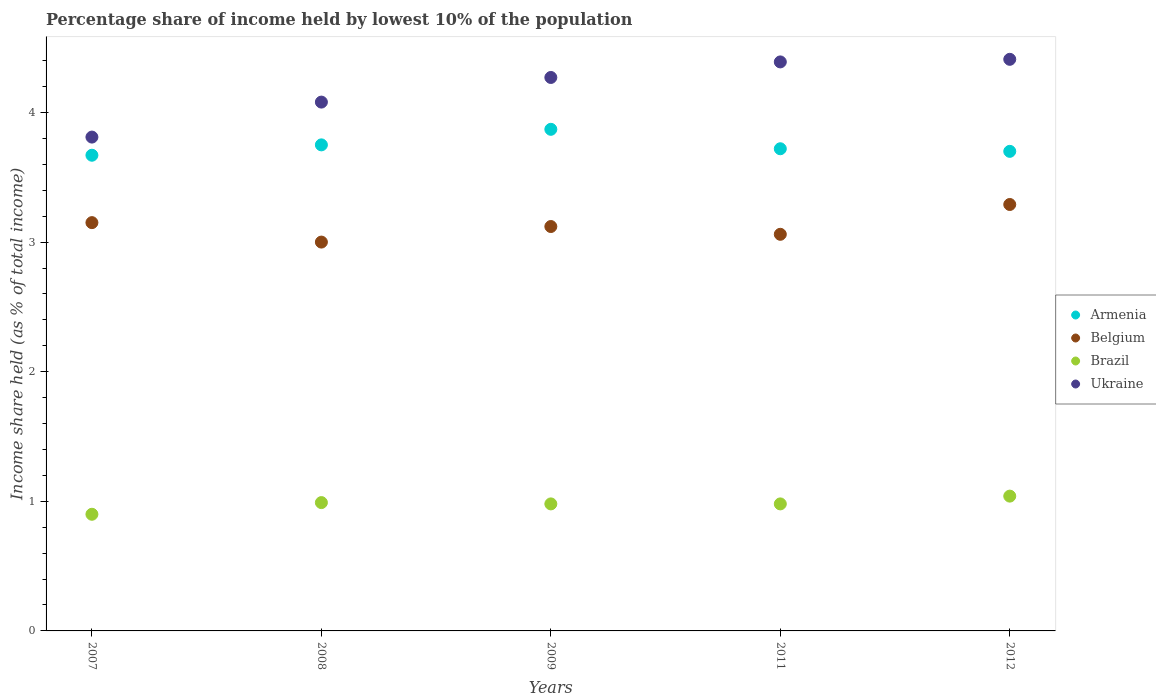How many different coloured dotlines are there?
Make the answer very short. 4. Is the number of dotlines equal to the number of legend labels?
Make the answer very short. Yes. What is the percentage share of income held by lowest 10% of the population in Armenia in 2011?
Your answer should be very brief. 3.72. Across all years, what is the maximum percentage share of income held by lowest 10% of the population in Belgium?
Keep it short and to the point. 3.29. Across all years, what is the minimum percentage share of income held by lowest 10% of the population in Ukraine?
Your answer should be very brief. 3.81. In which year was the percentage share of income held by lowest 10% of the population in Brazil maximum?
Keep it short and to the point. 2012. In which year was the percentage share of income held by lowest 10% of the population in Ukraine minimum?
Give a very brief answer. 2007. What is the total percentage share of income held by lowest 10% of the population in Belgium in the graph?
Your response must be concise. 15.62. What is the difference between the percentage share of income held by lowest 10% of the population in Brazil in 2008 and that in 2009?
Your answer should be compact. 0.01. What is the difference between the percentage share of income held by lowest 10% of the population in Armenia in 2011 and the percentage share of income held by lowest 10% of the population in Ukraine in 2007?
Your response must be concise. -0.09. What is the average percentage share of income held by lowest 10% of the population in Belgium per year?
Provide a short and direct response. 3.12. In the year 2012, what is the difference between the percentage share of income held by lowest 10% of the population in Ukraine and percentage share of income held by lowest 10% of the population in Belgium?
Offer a very short reply. 1.12. In how many years, is the percentage share of income held by lowest 10% of the population in Armenia greater than 0.8 %?
Provide a short and direct response. 5. What is the ratio of the percentage share of income held by lowest 10% of the population in Brazil in 2009 to that in 2012?
Offer a terse response. 0.94. What is the difference between the highest and the second highest percentage share of income held by lowest 10% of the population in Ukraine?
Offer a very short reply. 0.02. What is the difference between the highest and the lowest percentage share of income held by lowest 10% of the population in Armenia?
Keep it short and to the point. 0.2. In how many years, is the percentage share of income held by lowest 10% of the population in Ukraine greater than the average percentage share of income held by lowest 10% of the population in Ukraine taken over all years?
Provide a short and direct response. 3. Is the sum of the percentage share of income held by lowest 10% of the population in Armenia in 2008 and 2009 greater than the maximum percentage share of income held by lowest 10% of the population in Brazil across all years?
Your response must be concise. Yes. Is it the case that in every year, the sum of the percentage share of income held by lowest 10% of the population in Belgium and percentage share of income held by lowest 10% of the population in Brazil  is greater than the percentage share of income held by lowest 10% of the population in Ukraine?
Your response must be concise. No. Does the percentage share of income held by lowest 10% of the population in Ukraine monotonically increase over the years?
Provide a short and direct response. Yes. How many dotlines are there?
Give a very brief answer. 4. What is the difference between two consecutive major ticks on the Y-axis?
Your answer should be compact. 1. Are the values on the major ticks of Y-axis written in scientific E-notation?
Keep it short and to the point. No. Does the graph contain grids?
Offer a terse response. No. How many legend labels are there?
Ensure brevity in your answer.  4. What is the title of the graph?
Offer a very short reply. Percentage share of income held by lowest 10% of the population. Does "Central Europe" appear as one of the legend labels in the graph?
Provide a succinct answer. No. What is the label or title of the X-axis?
Keep it short and to the point. Years. What is the label or title of the Y-axis?
Offer a very short reply. Income share held (as % of total income). What is the Income share held (as % of total income) of Armenia in 2007?
Make the answer very short. 3.67. What is the Income share held (as % of total income) in Belgium in 2007?
Keep it short and to the point. 3.15. What is the Income share held (as % of total income) in Ukraine in 2007?
Give a very brief answer. 3.81. What is the Income share held (as % of total income) in Armenia in 2008?
Keep it short and to the point. 3.75. What is the Income share held (as % of total income) of Belgium in 2008?
Offer a terse response. 3. What is the Income share held (as % of total income) of Ukraine in 2008?
Your response must be concise. 4.08. What is the Income share held (as % of total income) in Armenia in 2009?
Keep it short and to the point. 3.87. What is the Income share held (as % of total income) of Belgium in 2009?
Provide a succinct answer. 3.12. What is the Income share held (as % of total income) of Brazil in 2009?
Offer a terse response. 0.98. What is the Income share held (as % of total income) in Ukraine in 2009?
Give a very brief answer. 4.27. What is the Income share held (as % of total income) in Armenia in 2011?
Ensure brevity in your answer.  3.72. What is the Income share held (as % of total income) in Belgium in 2011?
Your response must be concise. 3.06. What is the Income share held (as % of total income) of Brazil in 2011?
Your answer should be compact. 0.98. What is the Income share held (as % of total income) in Ukraine in 2011?
Make the answer very short. 4.39. What is the Income share held (as % of total income) in Belgium in 2012?
Offer a terse response. 3.29. What is the Income share held (as % of total income) in Brazil in 2012?
Your answer should be very brief. 1.04. What is the Income share held (as % of total income) in Ukraine in 2012?
Provide a short and direct response. 4.41. Across all years, what is the maximum Income share held (as % of total income) of Armenia?
Provide a succinct answer. 3.87. Across all years, what is the maximum Income share held (as % of total income) of Belgium?
Your response must be concise. 3.29. Across all years, what is the maximum Income share held (as % of total income) of Ukraine?
Keep it short and to the point. 4.41. Across all years, what is the minimum Income share held (as % of total income) of Armenia?
Your response must be concise. 3.67. Across all years, what is the minimum Income share held (as % of total income) of Belgium?
Provide a succinct answer. 3. Across all years, what is the minimum Income share held (as % of total income) in Ukraine?
Make the answer very short. 3.81. What is the total Income share held (as % of total income) in Armenia in the graph?
Offer a terse response. 18.71. What is the total Income share held (as % of total income) in Belgium in the graph?
Give a very brief answer. 15.62. What is the total Income share held (as % of total income) in Brazil in the graph?
Offer a terse response. 4.89. What is the total Income share held (as % of total income) in Ukraine in the graph?
Your answer should be compact. 20.96. What is the difference between the Income share held (as % of total income) of Armenia in 2007 and that in 2008?
Provide a short and direct response. -0.08. What is the difference between the Income share held (as % of total income) of Brazil in 2007 and that in 2008?
Your response must be concise. -0.09. What is the difference between the Income share held (as % of total income) of Ukraine in 2007 and that in 2008?
Your answer should be compact. -0.27. What is the difference between the Income share held (as % of total income) of Belgium in 2007 and that in 2009?
Keep it short and to the point. 0.03. What is the difference between the Income share held (as % of total income) of Brazil in 2007 and that in 2009?
Give a very brief answer. -0.08. What is the difference between the Income share held (as % of total income) in Ukraine in 2007 and that in 2009?
Give a very brief answer. -0.46. What is the difference between the Income share held (as % of total income) of Belgium in 2007 and that in 2011?
Give a very brief answer. 0.09. What is the difference between the Income share held (as % of total income) in Brazil in 2007 and that in 2011?
Offer a very short reply. -0.08. What is the difference between the Income share held (as % of total income) of Ukraine in 2007 and that in 2011?
Your response must be concise. -0.58. What is the difference between the Income share held (as % of total income) in Armenia in 2007 and that in 2012?
Your answer should be very brief. -0.03. What is the difference between the Income share held (as % of total income) in Belgium in 2007 and that in 2012?
Your answer should be very brief. -0.14. What is the difference between the Income share held (as % of total income) in Brazil in 2007 and that in 2012?
Offer a terse response. -0.14. What is the difference between the Income share held (as % of total income) of Ukraine in 2007 and that in 2012?
Keep it short and to the point. -0.6. What is the difference between the Income share held (as % of total income) in Armenia in 2008 and that in 2009?
Offer a terse response. -0.12. What is the difference between the Income share held (as % of total income) in Belgium in 2008 and that in 2009?
Ensure brevity in your answer.  -0.12. What is the difference between the Income share held (as % of total income) in Brazil in 2008 and that in 2009?
Provide a short and direct response. 0.01. What is the difference between the Income share held (as % of total income) of Ukraine in 2008 and that in 2009?
Make the answer very short. -0.19. What is the difference between the Income share held (as % of total income) of Armenia in 2008 and that in 2011?
Your answer should be compact. 0.03. What is the difference between the Income share held (as % of total income) in Belgium in 2008 and that in 2011?
Ensure brevity in your answer.  -0.06. What is the difference between the Income share held (as % of total income) of Ukraine in 2008 and that in 2011?
Offer a very short reply. -0.31. What is the difference between the Income share held (as % of total income) of Armenia in 2008 and that in 2012?
Make the answer very short. 0.05. What is the difference between the Income share held (as % of total income) in Belgium in 2008 and that in 2012?
Your answer should be very brief. -0.29. What is the difference between the Income share held (as % of total income) of Brazil in 2008 and that in 2012?
Your answer should be compact. -0.05. What is the difference between the Income share held (as % of total income) of Ukraine in 2008 and that in 2012?
Offer a very short reply. -0.33. What is the difference between the Income share held (as % of total income) of Belgium in 2009 and that in 2011?
Your answer should be very brief. 0.06. What is the difference between the Income share held (as % of total income) of Brazil in 2009 and that in 2011?
Make the answer very short. 0. What is the difference between the Income share held (as % of total income) in Ukraine in 2009 and that in 2011?
Provide a succinct answer. -0.12. What is the difference between the Income share held (as % of total income) of Armenia in 2009 and that in 2012?
Keep it short and to the point. 0.17. What is the difference between the Income share held (as % of total income) of Belgium in 2009 and that in 2012?
Keep it short and to the point. -0.17. What is the difference between the Income share held (as % of total income) of Brazil in 2009 and that in 2012?
Your answer should be compact. -0.06. What is the difference between the Income share held (as % of total income) in Ukraine in 2009 and that in 2012?
Your response must be concise. -0.14. What is the difference between the Income share held (as % of total income) in Belgium in 2011 and that in 2012?
Your response must be concise. -0.23. What is the difference between the Income share held (as % of total income) in Brazil in 2011 and that in 2012?
Make the answer very short. -0.06. What is the difference between the Income share held (as % of total income) in Ukraine in 2011 and that in 2012?
Provide a short and direct response. -0.02. What is the difference between the Income share held (as % of total income) in Armenia in 2007 and the Income share held (as % of total income) in Belgium in 2008?
Your response must be concise. 0.67. What is the difference between the Income share held (as % of total income) of Armenia in 2007 and the Income share held (as % of total income) of Brazil in 2008?
Make the answer very short. 2.68. What is the difference between the Income share held (as % of total income) in Armenia in 2007 and the Income share held (as % of total income) in Ukraine in 2008?
Ensure brevity in your answer.  -0.41. What is the difference between the Income share held (as % of total income) in Belgium in 2007 and the Income share held (as % of total income) in Brazil in 2008?
Provide a succinct answer. 2.16. What is the difference between the Income share held (as % of total income) in Belgium in 2007 and the Income share held (as % of total income) in Ukraine in 2008?
Your answer should be very brief. -0.93. What is the difference between the Income share held (as % of total income) of Brazil in 2007 and the Income share held (as % of total income) of Ukraine in 2008?
Your answer should be very brief. -3.18. What is the difference between the Income share held (as % of total income) in Armenia in 2007 and the Income share held (as % of total income) in Belgium in 2009?
Keep it short and to the point. 0.55. What is the difference between the Income share held (as % of total income) of Armenia in 2007 and the Income share held (as % of total income) of Brazil in 2009?
Make the answer very short. 2.69. What is the difference between the Income share held (as % of total income) of Armenia in 2007 and the Income share held (as % of total income) of Ukraine in 2009?
Provide a short and direct response. -0.6. What is the difference between the Income share held (as % of total income) in Belgium in 2007 and the Income share held (as % of total income) in Brazil in 2009?
Your response must be concise. 2.17. What is the difference between the Income share held (as % of total income) of Belgium in 2007 and the Income share held (as % of total income) of Ukraine in 2009?
Provide a succinct answer. -1.12. What is the difference between the Income share held (as % of total income) of Brazil in 2007 and the Income share held (as % of total income) of Ukraine in 2009?
Your response must be concise. -3.37. What is the difference between the Income share held (as % of total income) in Armenia in 2007 and the Income share held (as % of total income) in Belgium in 2011?
Make the answer very short. 0.61. What is the difference between the Income share held (as % of total income) in Armenia in 2007 and the Income share held (as % of total income) in Brazil in 2011?
Ensure brevity in your answer.  2.69. What is the difference between the Income share held (as % of total income) of Armenia in 2007 and the Income share held (as % of total income) of Ukraine in 2011?
Your answer should be very brief. -0.72. What is the difference between the Income share held (as % of total income) in Belgium in 2007 and the Income share held (as % of total income) in Brazil in 2011?
Your answer should be very brief. 2.17. What is the difference between the Income share held (as % of total income) of Belgium in 2007 and the Income share held (as % of total income) of Ukraine in 2011?
Make the answer very short. -1.24. What is the difference between the Income share held (as % of total income) of Brazil in 2007 and the Income share held (as % of total income) of Ukraine in 2011?
Your response must be concise. -3.49. What is the difference between the Income share held (as % of total income) of Armenia in 2007 and the Income share held (as % of total income) of Belgium in 2012?
Offer a very short reply. 0.38. What is the difference between the Income share held (as % of total income) of Armenia in 2007 and the Income share held (as % of total income) of Brazil in 2012?
Keep it short and to the point. 2.63. What is the difference between the Income share held (as % of total income) in Armenia in 2007 and the Income share held (as % of total income) in Ukraine in 2012?
Your answer should be very brief. -0.74. What is the difference between the Income share held (as % of total income) of Belgium in 2007 and the Income share held (as % of total income) of Brazil in 2012?
Provide a succinct answer. 2.11. What is the difference between the Income share held (as % of total income) of Belgium in 2007 and the Income share held (as % of total income) of Ukraine in 2012?
Your answer should be very brief. -1.26. What is the difference between the Income share held (as % of total income) of Brazil in 2007 and the Income share held (as % of total income) of Ukraine in 2012?
Make the answer very short. -3.51. What is the difference between the Income share held (as % of total income) in Armenia in 2008 and the Income share held (as % of total income) in Belgium in 2009?
Make the answer very short. 0.63. What is the difference between the Income share held (as % of total income) in Armenia in 2008 and the Income share held (as % of total income) in Brazil in 2009?
Ensure brevity in your answer.  2.77. What is the difference between the Income share held (as % of total income) in Armenia in 2008 and the Income share held (as % of total income) in Ukraine in 2009?
Make the answer very short. -0.52. What is the difference between the Income share held (as % of total income) in Belgium in 2008 and the Income share held (as % of total income) in Brazil in 2009?
Make the answer very short. 2.02. What is the difference between the Income share held (as % of total income) of Belgium in 2008 and the Income share held (as % of total income) of Ukraine in 2009?
Offer a terse response. -1.27. What is the difference between the Income share held (as % of total income) of Brazil in 2008 and the Income share held (as % of total income) of Ukraine in 2009?
Offer a terse response. -3.28. What is the difference between the Income share held (as % of total income) in Armenia in 2008 and the Income share held (as % of total income) in Belgium in 2011?
Your response must be concise. 0.69. What is the difference between the Income share held (as % of total income) of Armenia in 2008 and the Income share held (as % of total income) of Brazil in 2011?
Provide a succinct answer. 2.77. What is the difference between the Income share held (as % of total income) in Armenia in 2008 and the Income share held (as % of total income) in Ukraine in 2011?
Provide a succinct answer. -0.64. What is the difference between the Income share held (as % of total income) of Belgium in 2008 and the Income share held (as % of total income) of Brazil in 2011?
Make the answer very short. 2.02. What is the difference between the Income share held (as % of total income) of Belgium in 2008 and the Income share held (as % of total income) of Ukraine in 2011?
Your answer should be very brief. -1.39. What is the difference between the Income share held (as % of total income) in Armenia in 2008 and the Income share held (as % of total income) in Belgium in 2012?
Your answer should be very brief. 0.46. What is the difference between the Income share held (as % of total income) in Armenia in 2008 and the Income share held (as % of total income) in Brazil in 2012?
Give a very brief answer. 2.71. What is the difference between the Income share held (as % of total income) of Armenia in 2008 and the Income share held (as % of total income) of Ukraine in 2012?
Your answer should be very brief. -0.66. What is the difference between the Income share held (as % of total income) in Belgium in 2008 and the Income share held (as % of total income) in Brazil in 2012?
Offer a very short reply. 1.96. What is the difference between the Income share held (as % of total income) in Belgium in 2008 and the Income share held (as % of total income) in Ukraine in 2012?
Provide a short and direct response. -1.41. What is the difference between the Income share held (as % of total income) in Brazil in 2008 and the Income share held (as % of total income) in Ukraine in 2012?
Provide a succinct answer. -3.42. What is the difference between the Income share held (as % of total income) of Armenia in 2009 and the Income share held (as % of total income) of Belgium in 2011?
Offer a terse response. 0.81. What is the difference between the Income share held (as % of total income) in Armenia in 2009 and the Income share held (as % of total income) in Brazil in 2011?
Offer a terse response. 2.89. What is the difference between the Income share held (as % of total income) in Armenia in 2009 and the Income share held (as % of total income) in Ukraine in 2011?
Offer a terse response. -0.52. What is the difference between the Income share held (as % of total income) in Belgium in 2009 and the Income share held (as % of total income) in Brazil in 2011?
Give a very brief answer. 2.14. What is the difference between the Income share held (as % of total income) of Belgium in 2009 and the Income share held (as % of total income) of Ukraine in 2011?
Your answer should be very brief. -1.27. What is the difference between the Income share held (as % of total income) in Brazil in 2009 and the Income share held (as % of total income) in Ukraine in 2011?
Provide a succinct answer. -3.41. What is the difference between the Income share held (as % of total income) of Armenia in 2009 and the Income share held (as % of total income) of Belgium in 2012?
Give a very brief answer. 0.58. What is the difference between the Income share held (as % of total income) in Armenia in 2009 and the Income share held (as % of total income) in Brazil in 2012?
Provide a short and direct response. 2.83. What is the difference between the Income share held (as % of total income) in Armenia in 2009 and the Income share held (as % of total income) in Ukraine in 2012?
Give a very brief answer. -0.54. What is the difference between the Income share held (as % of total income) of Belgium in 2009 and the Income share held (as % of total income) of Brazil in 2012?
Offer a terse response. 2.08. What is the difference between the Income share held (as % of total income) in Belgium in 2009 and the Income share held (as % of total income) in Ukraine in 2012?
Your answer should be very brief. -1.29. What is the difference between the Income share held (as % of total income) of Brazil in 2009 and the Income share held (as % of total income) of Ukraine in 2012?
Your answer should be compact. -3.43. What is the difference between the Income share held (as % of total income) of Armenia in 2011 and the Income share held (as % of total income) of Belgium in 2012?
Offer a terse response. 0.43. What is the difference between the Income share held (as % of total income) of Armenia in 2011 and the Income share held (as % of total income) of Brazil in 2012?
Your answer should be very brief. 2.68. What is the difference between the Income share held (as % of total income) of Armenia in 2011 and the Income share held (as % of total income) of Ukraine in 2012?
Keep it short and to the point. -0.69. What is the difference between the Income share held (as % of total income) in Belgium in 2011 and the Income share held (as % of total income) in Brazil in 2012?
Your response must be concise. 2.02. What is the difference between the Income share held (as % of total income) of Belgium in 2011 and the Income share held (as % of total income) of Ukraine in 2012?
Provide a succinct answer. -1.35. What is the difference between the Income share held (as % of total income) of Brazil in 2011 and the Income share held (as % of total income) of Ukraine in 2012?
Provide a succinct answer. -3.43. What is the average Income share held (as % of total income) of Armenia per year?
Provide a succinct answer. 3.74. What is the average Income share held (as % of total income) of Belgium per year?
Your answer should be compact. 3.12. What is the average Income share held (as % of total income) in Ukraine per year?
Ensure brevity in your answer.  4.19. In the year 2007, what is the difference between the Income share held (as % of total income) in Armenia and Income share held (as % of total income) in Belgium?
Your answer should be very brief. 0.52. In the year 2007, what is the difference between the Income share held (as % of total income) in Armenia and Income share held (as % of total income) in Brazil?
Make the answer very short. 2.77. In the year 2007, what is the difference between the Income share held (as % of total income) in Armenia and Income share held (as % of total income) in Ukraine?
Provide a succinct answer. -0.14. In the year 2007, what is the difference between the Income share held (as % of total income) in Belgium and Income share held (as % of total income) in Brazil?
Your response must be concise. 2.25. In the year 2007, what is the difference between the Income share held (as % of total income) of Belgium and Income share held (as % of total income) of Ukraine?
Your response must be concise. -0.66. In the year 2007, what is the difference between the Income share held (as % of total income) in Brazil and Income share held (as % of total income) in Ukraine?
Keep it short and to the point. -2.91. In the year 2008, what is the difference between the Income share held (as % of total income) of Armenia and Income share held (as % of total income) of Belgium?
Offer a very short reply. 0.75. In the year 2008, what is the difference between the Income share held (as % of total income) of Armenia and Income share held (as % of total income) of Brazil?
Make the answer very short. 2.76. In the year 2008, what is the difference between the Income share held (as % of total income) in Armenia and Income share held (as % of total income) in Ukraine?
Provide a succinct answer. -0.33. In the year 2008, what is the difference between the Income share held (as % of total income) of Belgium and Income share held (as % of total income) of Brazil?
Give a very brief answer. 2.01. In the year 2008, what is the difference between the Income share held (as % of total income) in Belgium and Income share held (as % of total income) in Ukraine?
Offer a very short reply. -1.08. In the year 2008, what is the difference between the Income share held (as % of total income) in Brazil and Income share held (as % of total income) in Ukraine?
Ensure brevity in your answer.  -3.09. In the year 2009, what is the difference between the Income share held (as % of total income) in Armenia and Income share held (as % of total income) in Brazil?
Your answer should be compact. 2.89. In the year 2009, what is the difference between the Income share held (as % of total income) of Armenia and Income share held (as % of total income) of Ukraine?
Your response must be concise. -0.4. In the year 2009, what is the difference between the Income share held (as % of total income) of Belgium and Income share held (as % of total income) of Brazil?
Offer a terse response. 2.14. In the year 2009, what is the difference between the Income share held (as % of total income) in Belgium and Income share held (as % of total income) in Ukraine?
Your answer should be compact. -1.15. In the year 2009, what is the difference between the Income share held (as % of total income) in Brazil and Income share held (as % of total income) in Ukraine?
Offer a very short reply. -3.29. In the year 2011, what is the difference between the Income share held (as % of total income) of Armenia and Income share held (as % of total income) of Belgium?
Your answer should be compact. 0.66. In the year 2011, what is the difference between the Income share held (as % of total income) in Armenia and Income share held (as % of total income) in Brazil?
Offer a terse response. 2.74. In the year 2011, what is the difference between the Income share held (as % of total income) of Armenia and Income share held (as % of total income) of Ukraine?
Your answer should be compact. -0.67. In the year 2011, what is the difference between the Income share held (as % of total income) in Belgium and Income share held (as % of total income) in Brazil?
Keep it short and to the point. 2.08. In the year 2011, what is the difference between the Income share held (as % of total income) in Belgium and Income share held (as % of total income) in Ukraine?
Provide a short and direct response. -1.33. In the year 2011, what is the difference between the Income share held (as % of total income) in Brazil and Income share held (as % of total income) in Ukraine?
Give a very brief answer. -3.41. In the year 2012, what is the difference between the Income share held (as % of total income) in Armenia and Income share held (as % of total income) in Belgium?
Keep it short and to the point. 0.41. In the year 2012, what is the difference between the Income share held (as % of total income) of Armenia and Income share held (as % of total income) of Brazil?
Keep it short and to the point. 2.66. In the year 2012, what is the difference between the Income share held (as % of total income) in Armenia and Income share held (as % of total income) in Ukraine?
Offer a very short reply. -0.71. In the year 2012, what is the difference between the Income share held (as % of total income) of Belgium and Income share held (as % of total income) of Brazil?
Keep it short and to the point. 2.25. In the year 2012, what is the difference between the Income share held (as % of total income) of Belgium and Income share held (as % of total income) of Ukraine?
Provide a short and direct response. -1.12. In the year 2012, what is the difference between the Income share held (as % of total income) of Brazil and Income share held (as % of total income) of Ukraine?
Ensure brevity in your answer.  -3.37. What is the ratio of the Income share held (as % of total income) of Armenia in 2007 to that in 2008?
Your answer should be very brief. 0.98. What is the ratio of the Income share held (as % of total income) of Ukraine in 2007 to that in 2008?
Provide a succinct answer. 0.93. What is the ratio of the Income share held (as % of total income) in Armenia in 2007 to that in 2009?
Make the answer very short. 0.95. What is the ratio of the Income share held (as % of total income) of Belgium in 2007 to that in 2009?
Your answer should be very brief. 1.01. What is the ratio of the Income share held (as % of total income) of Brazil in 2007 to that in 2009?
Provide a short and direct response. 0.92. What is the ratio of the Income share held (as % of total income) of Ukraine in 2007 to that in 2009?
Give a very brief answer. 0.89. What is the ratio of the Income share held (as % of total income) in Armenia in 2007 to that in 2011?
Your answer should be very brief. 0.99. What is the ratio of the Income share held (as % of total income) in Belgium in 2007 to that in 2011?
Ensure brevity in your answer.  1.03. What is the ratio of the Income share held (as % of total income) of Brazil in 2007 to that in 2011?
Give a very brief answer. 0.92. What is the ratio of the Income share held (as % of total income) of Ukraine in 2007 to that in 2011?
Offer a very short reply. 0.87. What is the ratio of the Income share held (as % of total income) in Belgium in 2007 to that in 2012?
Your answer should be compact. 0.96. What is the ratio of the Income share held (as % of total income) of Brazil in 2007 to that in 2012?
Your answer should be compact. 0.87. What is the ratio of the Income share held (as % of total income) of Ukraine in 2007 to that in 2012?
Provide a succinct answer. 0.86. What is the ratio of the Income share held (as % of total income) of Armenia in 2008 to that in 2009?
Give a very brief answer. 0.97. What is the ratio of the Income share held (as % of total income) in Belgium in 2008 to that in 2009?
Ensure brevity in your answer.  0.96. What is the ratio of the Income share held (as % of total income) of Brazil in 2008 to that in 2009?
Provide a short and direct response. 1.01. What is the ratio of the Income share held (as % of total income) in Ukraine in 2008 to that in 2009?
Your answer should be compact. 0.96. What is the ratio of the Income share held (as % of total income) in Belgium in 2008 to that in 2011?
Offer a terse response. 0.98. What is the ratio of the Income share held (as % of total income) of Brazil in 2008 to that in 2011?
Keep it short and to the point. 1.01. What is the ratio of the Income share held (as % of total income) in Ukraine in 2008 to that in 2011?
Provide a short and direct response. 0.93. What is the ratio of the Income share held (as % of total income) in Armenia in 2008 to that in 2012?
Make the answer very short. 1.01. What is the ratio of the Income share held (as % of total income) of Belgium in 2008 to that in 2012?
Keep it short and to the point. 0.91. What is the ratio of the Income share held (as % of total income) in Brazil in 2008 to that in 2012?
Your answer should be compact. 0.95. What is the ratio of the Income share held (as % of total income) of Ukraine in 2008 to that in 2012?
Your response must be concise. 0.93. What is the ratio of the Income share held (as % of total income) of Armenia in 2009 to that in 2011?
Make the answer very short. 1.04. What is the ratio of the Income share held (as % of total income) in Belgium in 2009 to that in 2011?
Keep it short and to the point. 1.02. What is the ratio of the Income share held (as % of total income) of Brazil in 2009 to that in 2011?
Your answer should be very brief. 1. What is the ratio of the Income share held (as % of total income) in Ukraine in 2009 to that in 2011?
Keep it short and to the point. 0.97. What is the ratio of the Income share held (as % of total income) in Armenia in 2009 to that in 2012?
Your response must be concise. 1.05. What is the ratio of the Income share held (as % of total income) in Belgium in 2009 to that in 2012?
Make the answer very short. 0.95. What is the ratio of the Income share held (as % of total income) in Brazil in 2009 to that in 2012?
Provide a short and direct response. 0.94. What is the ratio of the Income share held (as % of total income) in Ukraine in 2009 to that in 2012?
Your response must be concise. 0.97. What is the ratio of the Income share held (as % of total income) in Armenia in 2011 to that in 2012?
Provide a short and direct response. 1.01. What is the ratio of the Income share held (as % of total income) of Belgium in 2011 to that in 2012?
Ensure brevity in your answer.  0.93. What is the ratio of the Income share held (as % of total income) in Brazil in 2011 to that in 2012?
Make the answer very short. 0.94. What is the ratio of the Income share held (as % of total income) of Ukraine in 2011 to that in 2012?
Your response must be concise. 1. What is the difference between the highest and the second highest Income share held (as % of total income) in Armenia?
Your answer should be very brief. 0.12. What is the difference between the highest and the second highest Income share held (as % of total income) in Belgium?
Your response must be concise. 0.14. What is the difference between the highest and the lowest Income share held (as % of total income) of Armenia?
Ensure brevity in your answer.  0.2. What is the difference between the highest and the lowest Income share held (as % of total income) in Belgium?
Your answer should be very brief. 0.29. What is the difference between the highest and the lowest Income share held (as % of total income) in Brazil?
Your response must be concise. 0.14. 